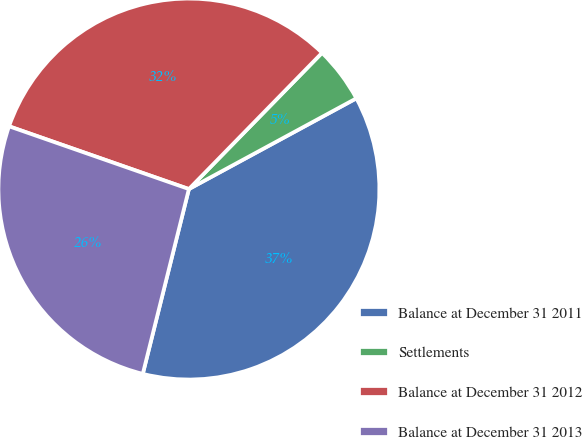<chart> <loc_0><loc_0><loc_500><loc_500><pie_chart><fcel>Balance at December 31 2011<fcel>Settlements<fcel>Balance at December 31 2012<fcel>Balance at December 31 2013<nl><fcel>36.79%<fcel>4.78%<fcel>31.97%<fcel>26.45%<nl></chart> 